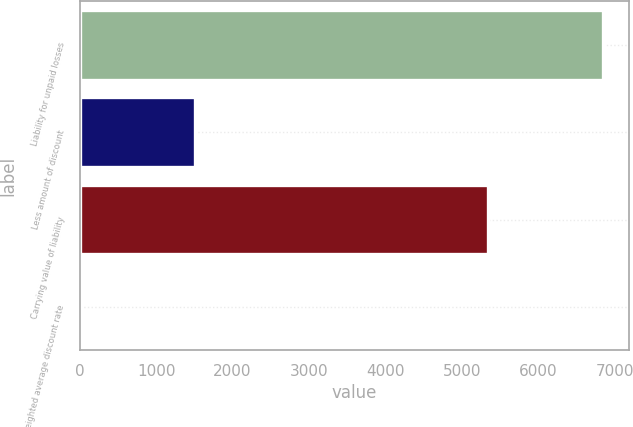Convert chart to OTSL. <chart><loc_0><loc_0><loc_500><loc_500><bar_chart><fcel>Liability for unpaid losses<fcel>Less amount of discount<fcel>Carrying value of liability<fcel>Weighted average discount rate<nl><fcel>6841<fcel>1502<fcel>5339<fcel>4.5<nl></chart> 